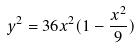<formula> <loc_0><loc_0><loc_500><loc_500>y ^ { 2 } = 3 6 x ^ { 2 } ( 1 - \frac { x ^ { 2 } } { 9 } )</formula> 